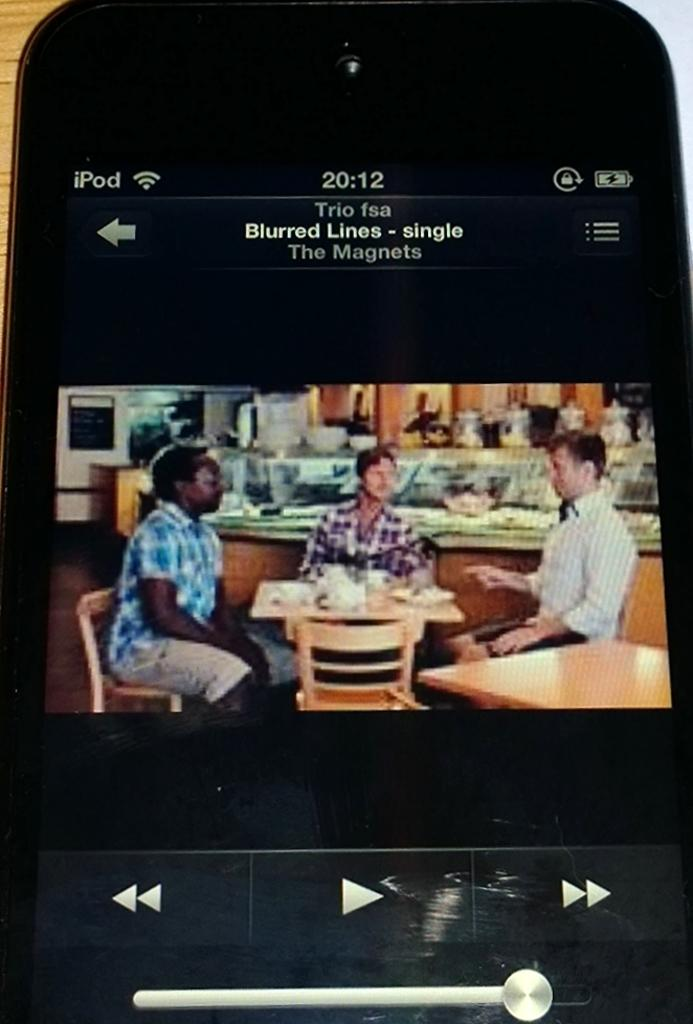How many people are in the image? There are three persons in the image. What are the persons doing in the image? The persons are sitting on chairs. What object can be seen in the image besides the chairs? There is a table in the image. What type of grape is being used as a paperweight on the table in the image? There is no grape present in the image, and therefore no such object is being used as a paperweight. 